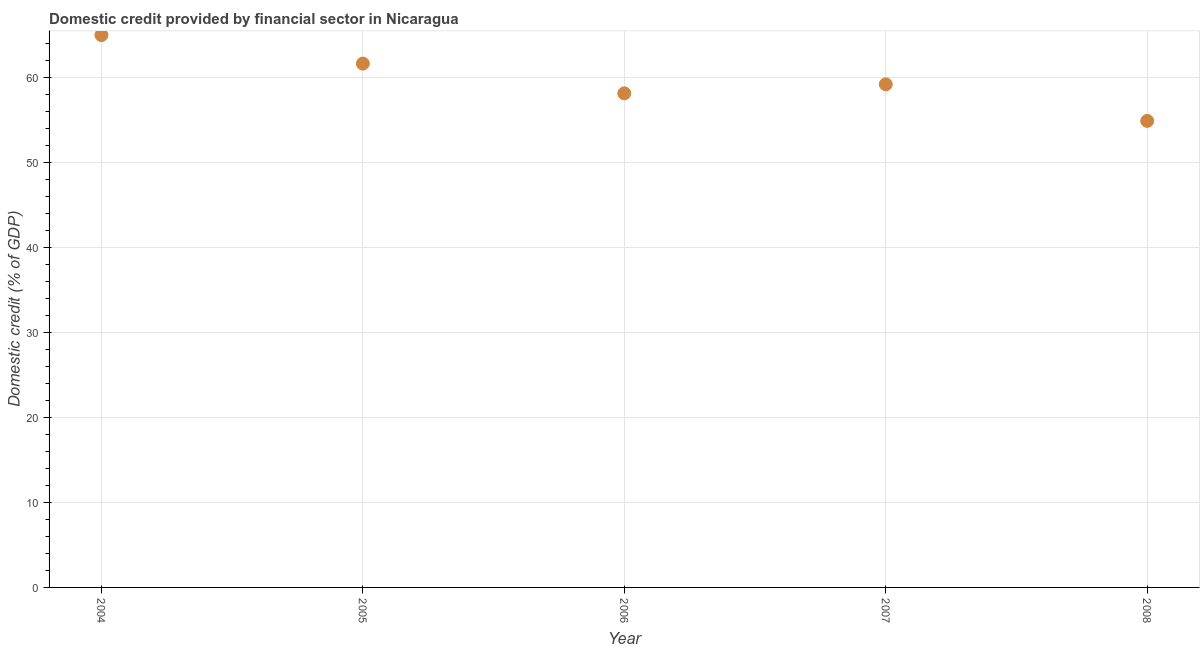What is the domestic credit provided by financial sector in 2006?
Offer a terse response. 58.14. Across all years, what is the maximum domestic credit provided by financial sector?
Your response must be concise. 64.99. Across all years, what is the minimum domestic credit provided by financial sector?
Give a very brief answer. 54.89. In which year was the domestic credit provided by financial sector maximum?
Your answer should be very brief. 2004. What is the sum of the domestic credit provided by financial sector?
Your answer should be very brief. 298.85. What is the difference between the domestic credit provided by financial sector in 2005 and 2008?
Offer a terse response. 6.74. What is the average domestic credit provided by financial sector per year?
Your response must be concise. 59.77. What is the median domestic credit provided by financial sector?
Provide a short and direct response. 59.2. In how many years, is the domestic credit provided by financial sector greater than 2 %?
Offer a very short reply. 5. Do a majority of the years between 2007 and 2004 (inclusive) have domestic credit provided by financial sector greater than 10 %?
Your response must be concise. Yes. What is the ratio of the domestic credit provided by financial sector in 2007 to that in 2008?
Provide a succinct answer. 1.08. Is the domestic credit provided by financial sector in 2005 less than that in 2006?
Provide a succinct answer. No. What is the difference between the highest and the second highest domestic credit provided by financial sector?
Make the answer very short. 3.35. What is the difference between the highest and the lowest domestic credit provided by financial sector?
Your response must be concise. 10.09. In how many years, is the domestic credit provided by financial sector greater than the average domestic credit provided by financial sector taken over all years?
Make the answer very short. 2. Does the domestic credit provided by financial sector monotonically increase over the years?
Provide a short and direct response. No. How many dotlines are there?
Your answer should be compact. 1. How many years are there in the graph?
Give a very brief answer. 5. What is the difference between two consecutive major ticks on the Y-axis?
Your answer should be very brief. 10. Are the values on the major ticks of Y-axis written in scientific E-notation?
Ensure brevity in your answer.  No. Does the graph contain grids?
Your answer should be very brief. Yes. What is the title of the graph?
Your answer should be very brief. Domestic credit provided by financial sector in Nicaragua. What is the label or title of the Y-axis?
Keep it short and to the point. Domestic credit (% of GDP). What is the Domestic credit (% of GDP) in 2004?
Ensure brevity in your answer.  64.99. What is the Domestic credit (% of GDP) in 2005?
Provide a short and direct response. 61.64. What is the Domestic credit (% of GDP) in 2006?
Your answer should be compact. 58.14. What is the Domestic credit (% of GDP) in 2007?
Ensure brevity in your answer.  59.2. What is the Domestic credit (% of GDP) in 2008?
Provide a succinct answer. 54.89. What is the difference between the Domestic credit (% of GDP) in 2004 and 2005?
Provide a short and direct response. 3.35. What is the difference between the Domestic credit (% of GDP) in 2004 and 2006?
Your answer should be compact. 6.85. What is the difference between the Domestic credit (% of GDP) in 2004 and 2007?
Ensure brevity in your answer.  5.79. What is the difference between the Domestic credit (% of GDP) in 2004 and 2008?
Make the answer very short. 10.09. What is the difference between the Domestic credit (% of GDP) in 2005 and 2006?
Provide a succinct answer. 3.5. What is the difference between the Domestic credit (% of GDP) in 2005 and 2007?
Provide a succinct answer. 2.44. What is the difference between the Domestic credit (% of GDP) in 2005 and 2008?
Make the answer very short. 6.74. What is the difference between the Domestic credit (% of GDP) in 2006 and 2007?
Provide a succinct answer. -1.06. What is the difference between the Domestic credit (% of GDP) in 2006 and 2008?
Make the answer very short. 3.24. What is the difference between the Domestic credit (% of GDP) in 2007 and 2008?
Provide a short and direct response. 4.3. What is the ratio of the Domestic credit (% of GDP) in 2004 to that in 2005?
Ensure brevity in your answer.  1.05. What is the ratio of the Domestic credit (% of GDP) in 2004 to that in 2006?
Offer a terse response. 1.12. What is the ratio of the Domestic credit (% of GDP) in 2004 to that in 2007?
Your response must be concise. 1.1. What is the ratio of the Domestic credit (% of GDP) in 2004 to that in 2008?
Make the answer very short. 1.18. What is the ratio of the Domestic credit (% of GDP) in 2005 to that in 2006?
Give a very brief answer. 1.06. What is the ratio of the Domestic credit (% of GDP) in 2005 to that in 2007?
Your answer should be compact. 1.04. What is the ratio of the Domestic credit (% of GDP) in 2005 to that in 2008?
Make the answer very short. 1.12. What is the ratio of the Domestic credit (% of GDP) in 2006 to that in 2008?
Offer a terse response. 1.06. What is the ratio of the Domestic credit (% of GDP) in 2007 to that in 2008?
Your response must be concise. 1.08. 